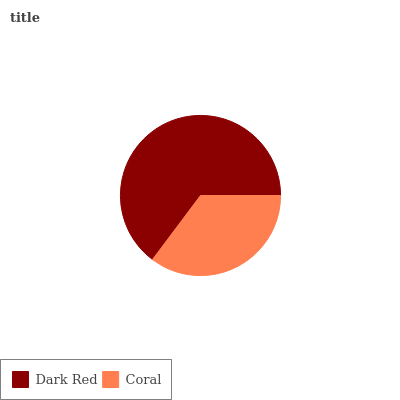Is Coral the minimum?
Answer yes or no. Yes. Is Dark Red the maximum?
Answer yes or no. Yes. Is Coral the maximum?
Answer yes or no. No. Is Dark Red greater than Coral?
Answer yes or no. Yes. Is Coral less than Dark Red?
Answer yes or no. Yes. Is Coral greater than Dark Red?
Answer yes or no. No. Is Dark Red less than Coral?
Answer yes or no. No. Is Dark Red the high median?
Answer yes or no. Yes. Is Coral the low median?
Answer yes or no. Yes. Is Coral the high median?
Answer yes or no. No. Is Dark Red the low median?
Answer yes or no. No. 